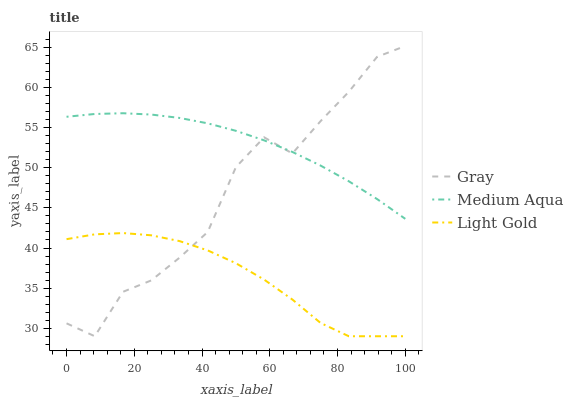Does Light Gold have the minimum area under the curve?
Answer yes or no. Yes. Does Medium Aqua have the maximum area under the curve?
Answer yes or no. Yes. Does Medium Aqua have the minimum area under the curve?
Answer yes or no. No. Does Light Gold have the maximum area under the curve?
Answer yes or no. No. Is Medium Aqua the smoothest?
Answer yes or no. Yes. Is Gray the roughest?
Answer yes or no. Yes. Is Light Gold the smoothest?
Answer yes or no. No. Is Light Gold the roughest?
Answer yes or no. No. Does Gray have the lowest value?
Answer yes or no. Yes. Does Medium Aqua have the lowest value?
Answer yes or no. No. Does Gray have the highest value?
Answer yes or no. Yes. Does Medium Aqua have the highest value?
Answer yes or no. No. Is Light Gold less than Medium Aqua?
Answer yes or no. Yes. Is Medium Aqua greater than Light Gold?
Answer yes or no. Yes. Does Light Gold intersect Gray?
Answer yes or no. Yes. Is Light Gold less than Gray?
Answer yes or no. No. Is Light Gold greater than Gray?
Answer yes or no. No. Does Light Gold intersect Medium Aqua?
Answer yes or no. No. 